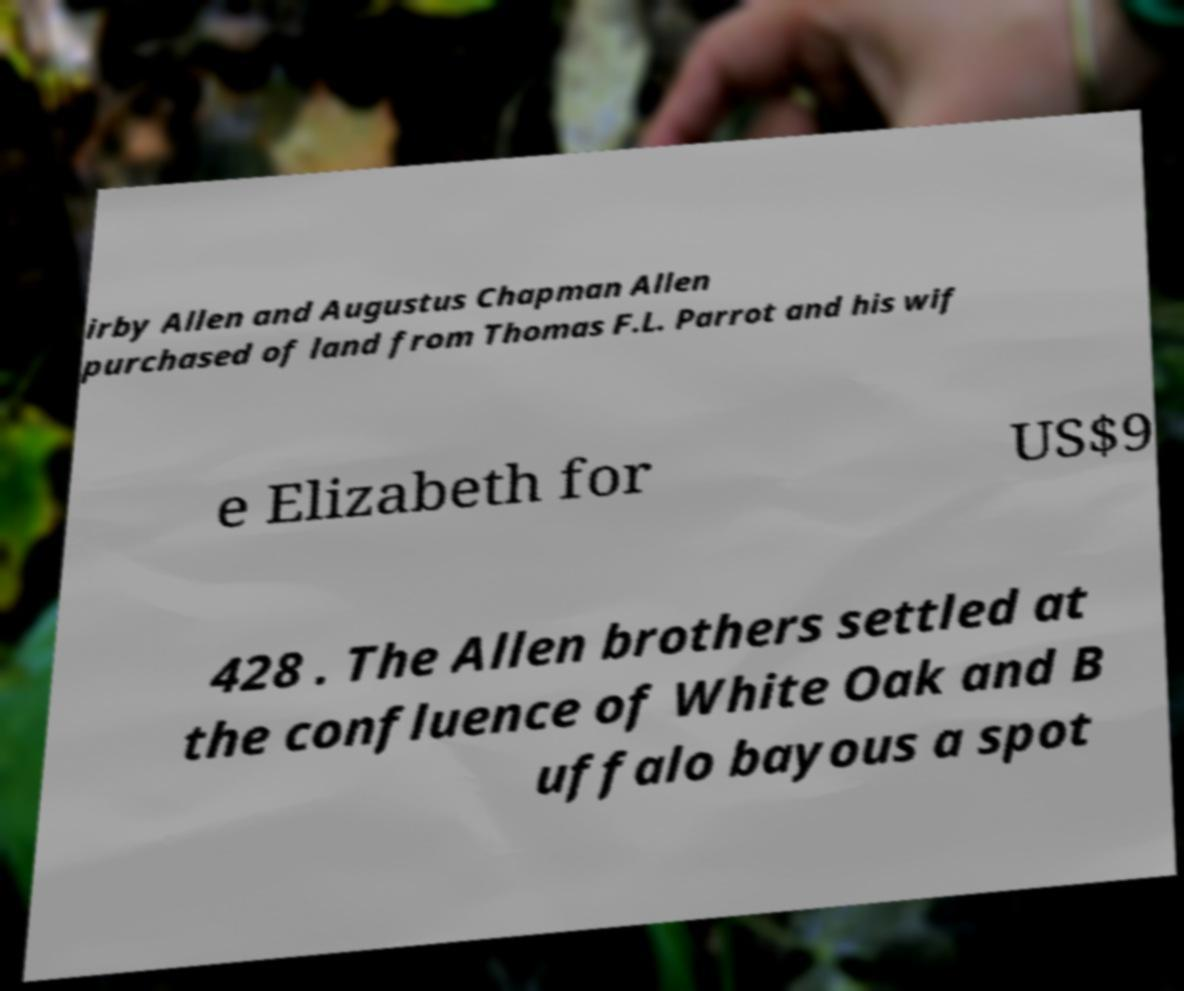Please identify and transcribe the text found in this image. irby Allen and Augustus Chapman Allen purchased of land from Thomas F.L. Parrot and his wif e Elizabeth for US$9 428 . The Allen brothers settled at the confluence of White Oak and B uffalo bayous a spot 